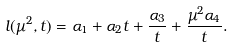Convert formula to latex. <formula><loc_0><loc_0><loc_500><loc_500>l ( \mu ^ { 2 } , t ) = \alpha _ { 1 } + \alpha _ { 2 } t + \frac { \alpha _ { 3 } } { t } + \frac { \mu ^ { 2 } \alpha _ { 4 } } { t } .</formula> 